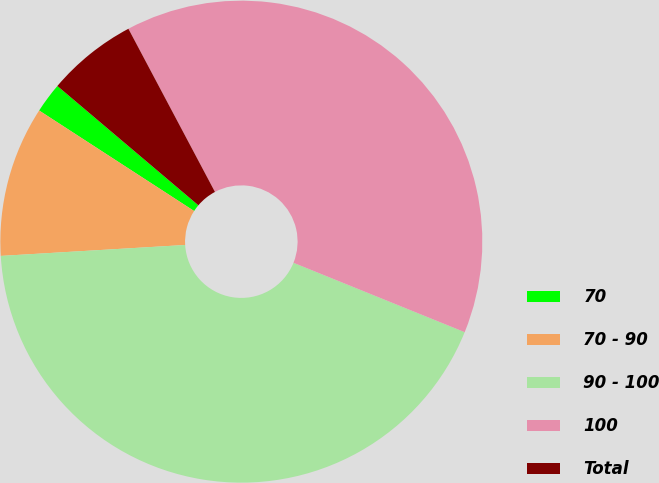<chart> <loc_0><loc_0><loc_500><loc_500><pie_chart><fcel>70<fcel>70 - 90<fcel>90 - 100<fcel>100<fcel>Total<nl><fcel>2.02%<fcel>10.1%<fcel>42.93%<fcel>38.89%<fcel>6.06%<nl></chart> 